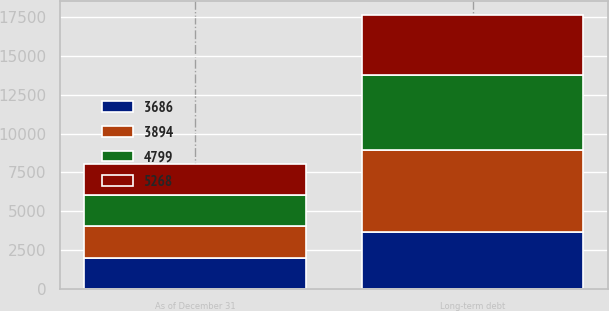Convert chart to OTSL. <chart><loc_0><loc_0><loc_500><loc_500><stacked_bar_chart><ecel><fcel>As of December 31<fcel>Long-term debt<nl><fcel>4799<fcel>2014<fcel>4799<nl><fcel>3894<fcel>2014<fcel>5268<nl><fcel>3686<fcel>2013<fcel>3686<nl><fcel>5268<fcel>2013<fcel>3894<nl></chart> 